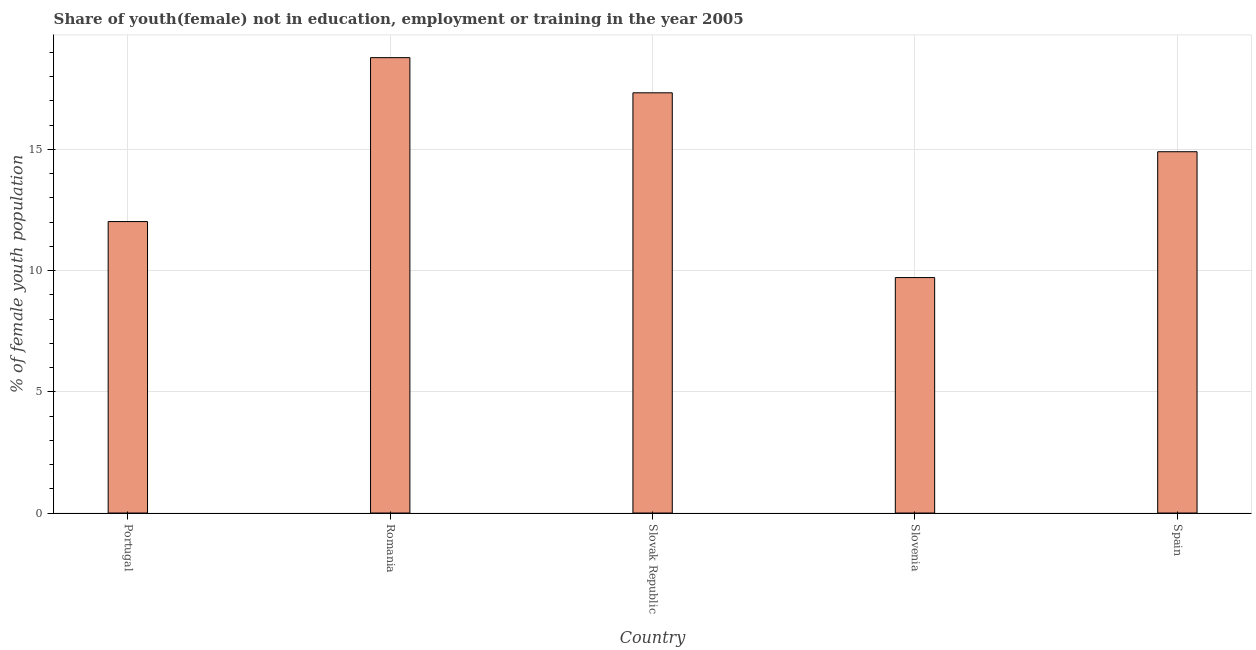Does the graph contain any zero values?
Provide a short and direct response. No. What is the title of the graph?
Give a very brief answer. Share of youth(female) not in education, employment or training in the year 2005. What is the label or title of the Y-axis?
Your answer should be compact. % of female youth population. What is the unemployed female youth population in Romania?
Your response must be concise. 18.78. Across all countries, what is the maximum unemployed female youth population?
Offer a very short reply. 18.78. Across all countries, what is the minimum unemployed female youth population?
Provide a succinct answer. 9.71. In which country was the unemployed female youth population maximum?
Keep it short and to the point. Romania. In which country was the unemployed female youth population minimum?
Keep it short and to the point. Slovenia. What is the sum of the unemployed female youth population?
Make the answer very short. 72.74. What is the difference between the unemployed female youth population in Portugal and Slovak Republic?
Provide a short and direct response. -5.31. What is the average unemployed female youth population per country?
Give a very brief answer. 14.55. What is the median unemployed female youth population?
Make the answer very short. 14.9. In how many countries, is the unemployed female youth population greater than 16 %?
Give a very brief answer. 2. What is the ratio of the unemployed female youth population in Portugal to that in Slovenia?
Your response must be concise. 1.24. Is the unemployed female youth population in Portugal less than that in Romania?
Ensure brevity in your answer.  Yes. Is the difference between the unemployed female youth population in Romania and Spain greater than the difference between any two countries?
Ensure brevity in your answer.  No. What is the difference between the highest and the second highest unemployed female youth population?
Your answer should be very brief. 1.45. Is the sum of the unemployed female youth population in Portugal and Romania greater than the maximum unemployed female youth population across all countries?
Keep it short and to the point. Yes. What is the difference between the highest and the lowest unemployed female youth population?
Your response must be concise. 9.07. In how many countries, is the unemployed female youth population greater than the average unemployed female youth population taken over all countries?
Offer a very short reply. 3. Are all the bars in the graph horizontal?
Provide a short and direct response. No. How many countries are there in the graph?
Keep it short and to the point. 5. What is the difference between two consecutive major ticks on the Y-axis?
Your answer should be very brief. 5. What is the % of female youth population of Portugal?
Provide a short and direct response. 12.02. What is the % of female youth population of Romania?
Provide a succinct answer. 18.78. What is the % of female youth population in Slovak Republic?
Your answer should be compact. 17.33. What is the % of female youth population in Slovenia?
Provide a short and direct response. 9.71. What is the % of female youth population of Spain?
Your answer should be compact. 14.9. What is the difference between the % of female youth population in Portugal and Romania?
Offer a terse response. -6.76. What is the difference between the % of female youth population in Portugal and Slovak Republic?
Provide a short and direct response. -5.31. What is the difference between the % of female youth population in Portugal and Slovenia?
Ensure brevity in your answer.  2.31. What is the difference between the % of female youth population in Portugal and Spain?
Your answer should be very brief. -2.88. What is the difference between the % of female youth population in Romania and Slovak Republic?
Provide a succinct answer. 1.45. What is the difference between the % of female youth population in Romania and Slovenia?
Keep it short and to the point. 9.07. What is the difference between the % of female youth population in Romania and Spain?
Keep it short and to the point. 3.88. What is the difference between the % of female youth population in Slovak Republic and Slovenia?
Offer a very short reply. 7.62. What is the difference between the % of female youth population in Slovak Republic and Spain?
Make the answer very short. 2.43. What is the difference between the % of female youth population in Slovenia and Spain?
Provide a short and direct response. -5.19. What is the ratio of the % of female youth population in Portugal to that in Romania?
Provide a short and direct response. 0.64. What is the ratio of the % of female youth population in Portugal to that in Slovak Republic?
Provide a succinct answer. 0.69. What is the ratio of the % of female youth population in Portugal to that in Slovenia?
Provide a succinct answer. 1.24. What is the ratio of the % of female youth population in Portugal to that in Spain?
Make the answer very short. 0.81. What is the ratio of the % of female youth population in Romania to that in Slovak Republic?
Offer a very short reply. 1.08. What is the ratio of the % of female youth population in Romania to that in Slovenia?
Give a very brief answer. 1.93. What is the ratio of the % of female youth population in Romania to that in Spain?
Your answer should be compact. 1.26. What is the ratio of the % of female youth population in Slovak Republic to that in Slovenia?
Keep it short and to the point. 1.78. What is the ratio of the % of female youth population in Slovak Republic to that in Spain?
Ensure brevity in your answer.  1.16. What is the ratio of the % of female youth population in Slovenia to that in Spain?
Provide a succinct answer. 0.65. 